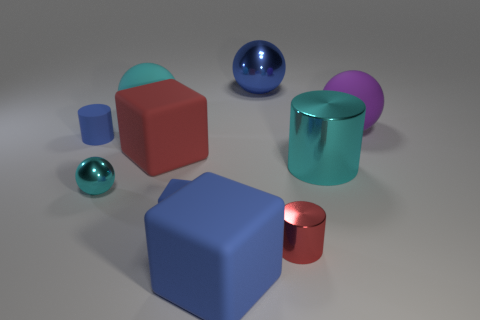How many cyan balls must be subtracted to get 1 cyan balls? 1 Subtract 1 cubes. How many cubes are left? 2 Subtract all tiny cylinders. How many cylinders are left? 1 Subtract all yellow balls. Subtract all blue cylinders. How many balls are left? 4 Subtract all cylinders. How many objects are left? 7 Subtract 0 brown cylinders. How many objects are left? 10 Subtract all brown rubber cubes. Subtract all blue cubes. How many objects are left? 8 Add 6 tiny blue matte things. How many tiny blue matte things are left? 8 Add 7 large blue metal things. How many large blue metal things exist? 8 